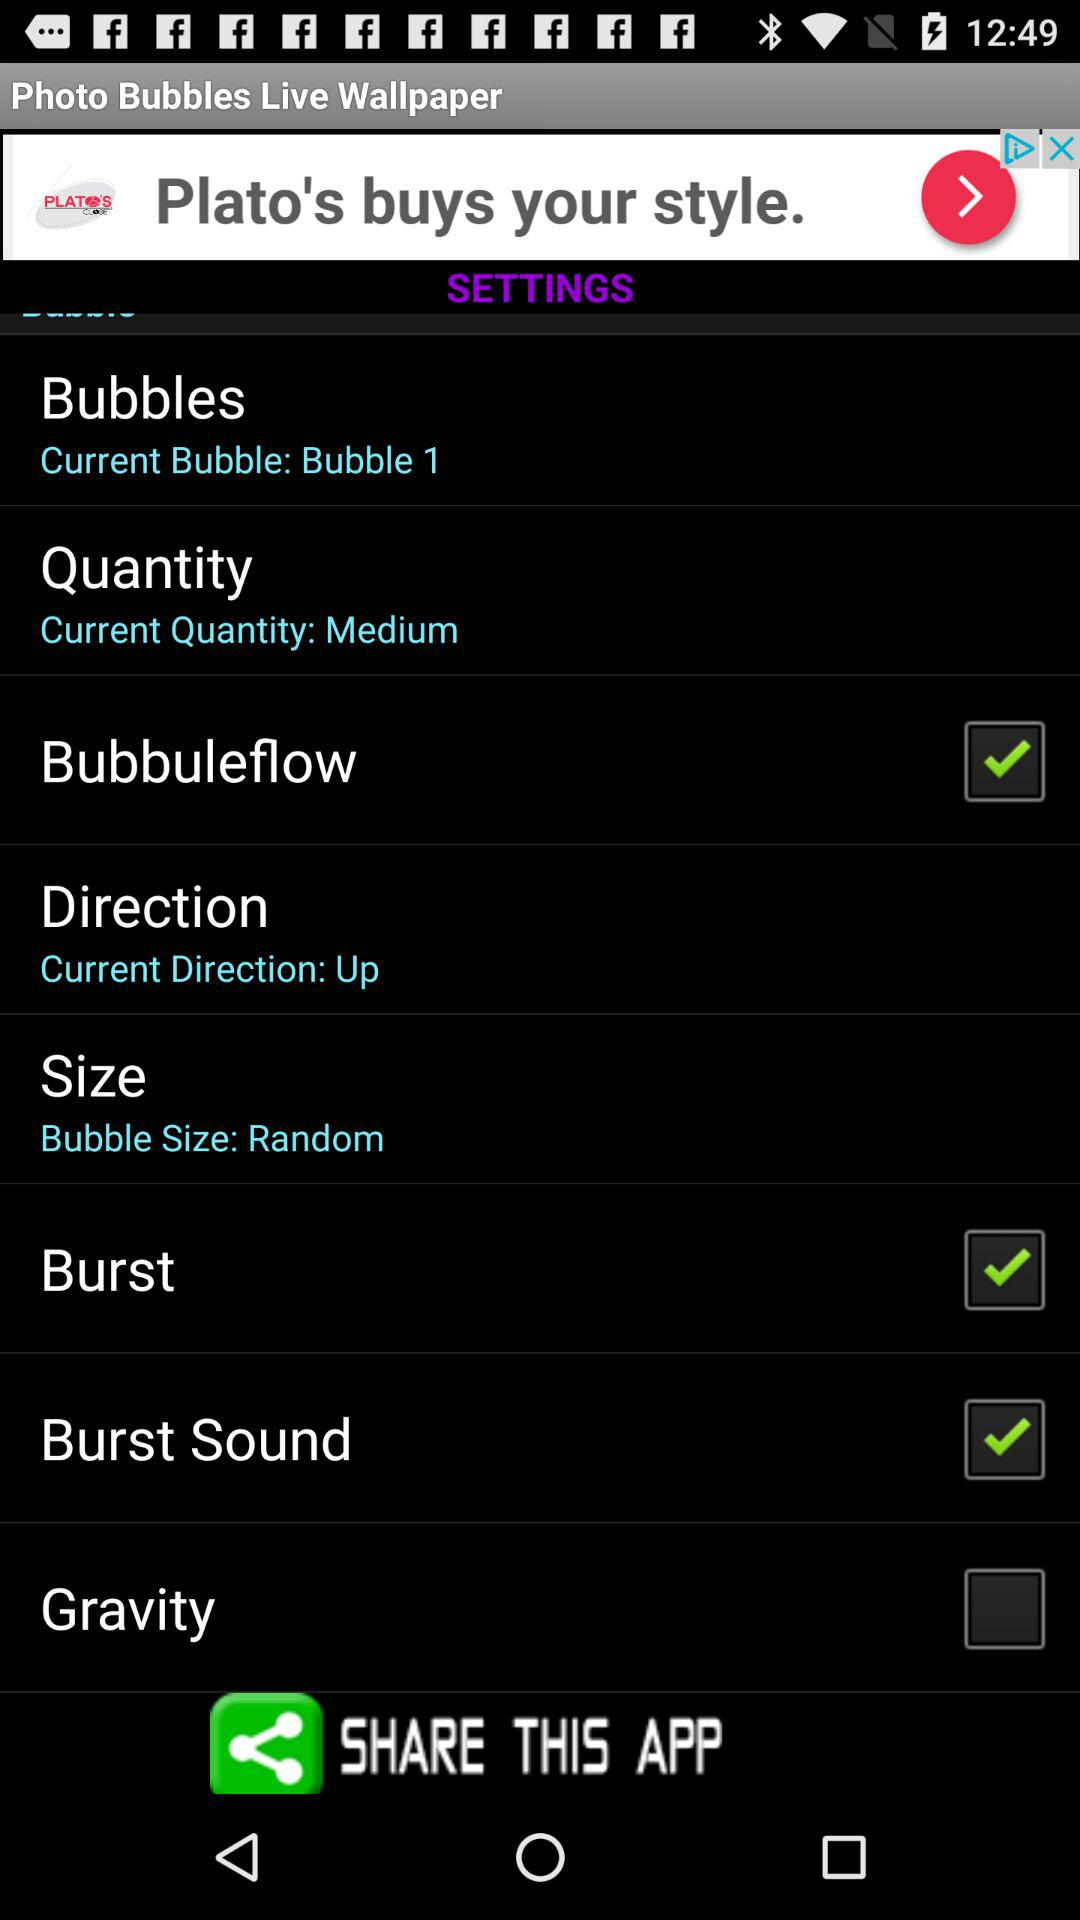Which option is unchecked? The option that is unchecked is "Gravity". 